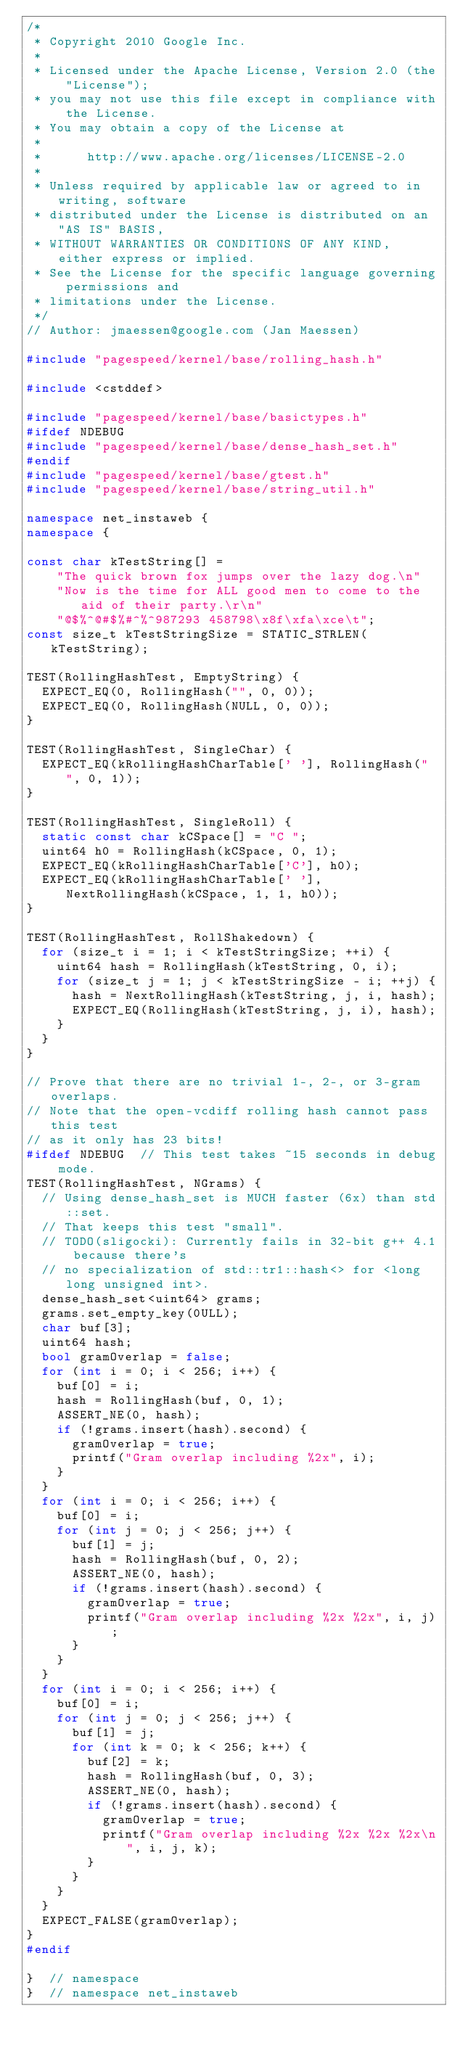Convert code to text. <code><loc_0><loc_0><loc_500><loc_500><_C++_>/*
 * Copyright 2010 Google Inc.
 *
 * Licensed under the Apache License, Version 2.0 (the "License");
 * you may not use this file except in compliance with the License.
 * You may obtain a copy of the License at
 *
 *      http://www.apache.org/licenses/LICENSE-2.0
 *
 * Unless required by applicable law or agreed to in writing, software
 * distributed under the License is distributed on an "AS IS" BASIS,
 * WITHOUT WARRANTIES OR CONDITIONS OF ANY KIND, either express or implied.
 * See the License for the specific language governing permissions and
 * limitations under the License.
 */
// Author: jmaessen@google.com (Jan Maessen)

#include "pagespeed/kernel/base/rolling_hash.h"

#include <cstddef>

#include "pagespeed/kernel/base/basictypes.h"
#ifdef NDEBUG
#include "pagespeed/kernel/base/dense_hash_set.h"
#endif
#include "pagespeed/kernel/base/gtest.h"
#include "pagespeed/kernel/base/string_util.h"

namespace net_instaweb {
namespace {

const char kTestString[] =
    "The quick brown fox jumps over the lazy dog.\n"
    "Now is the time for ALL good men to come to the aid of their party.\r\n"
    "@$%^@#$%#^%^987293 458798\x8f\xfa\xce\t";
const size_t kTestStringSize = STATIC_STRLEN(kTestString);

TEST(RollingHashTest, EmptyString) {
  EXPECT_EQ(0, RollingHash("", 0, 0));
  EXPECT_EQ(0, RollingHash(NULL, 0, 0));
}

TEST(RollingHashTest, SingleChar) {
  EXPECT_EQ(kRollingHashCharTable[' '], RollingHash(" ", 0, 1));
}

TEST(RollingHashTest, SingleRoll) {
  static const char kCSpace[] = "C ";
  uint64 h0 = RollingHash(kCSpace, 0, 1);
  EXPECT_EQ(kRollingHashCharTable['C'], h0);
  EXPECT_EQ(kRollingHashCharTable[' '], NextRollingHash(kCSpace, 1, 1, h0));
}

TEST(RollingHashTest, RollShakedown) {
  for (size_t i = 1; i < kTestStringSize; ++i) {
    uint64 hash = RollingHash(kTestString, 0, i);
    for (size_t j = 1; j < kTestStringSize - i; ++j) {
      hash = NextRollingHash(kTestString, j, i, hash);
      EXPECT_EQ(RollingHash(kTestString, j, i), hash);
    }
  }
}

// Prove that there are no trivial 1-, 2-, or 3-gram overlaps.
// Note that the open-vcdiff rolling hash cannot pass this test
// as it only has 23 bits!
#ifdef NDEBUG  // This test takes ~15 seconds in debug mode.
TEST(RollingHashTest, NGrams) {
  // Using dense_hash_set is MUCH faster (6x) than std::set.
  // That keeps this test "small".
  // TODO(sligocki): Currently fails in 32-bit g++ 4.1 because there's
  // no specialization of std::tr1::hash<> for <long long unsigned int>.
  dense_hash_set<uint64> grams;
  grams.set_empty_key(0ULL);
  char buf[3];
  uint64 hash;
  bool gramOverlap = false;
  for (int i = 0; i < 256; i++) {
    buf[0] = i;
    hash = RollingHash(buf, 0, 1);
    ASSERT_NE(0, hash);
    if (!grams.insert(hash).second) {
      gramOverlap = true;
      printf("Gram overlap including %2x", i);
    }
  }
  for (int i = 0; i < 256; i++) {
    buf[0] = i;
    for (int j = 0; j < 256; j++) {
      buf[1] = j;
      hash = RollingHash(buf, 0, 2);
      ASSERT_NE(0, hash);
      if (!grams.insert(hash).second) {
        gramOverlap = true;
        printf("Gram overlap including %2x %2x", i, j);
      }
    }
  }
  for (int i = 0; i < 256; i++) {
    buf[0] = i;
    for (int j = 0; j < 256; j++) {
      buf[1] = j;
      for (int k = 0; k < 256; k++) {
        buf[2] = k;
        hash = RollingHash(buf, 0, 3);
        ASSERT_NE(0, hash);
        if (!grams.insert(hash).second) {
          gramOverlap = true;
          printf("Gram overlap including %2x %2x %2x\n", i, j, k);
        }
      }
    }
  }
  EXPECT_FALSE(gramOverlap);
}
#endif

}  // namespace
}  // namespace net_instaweb
</code> 